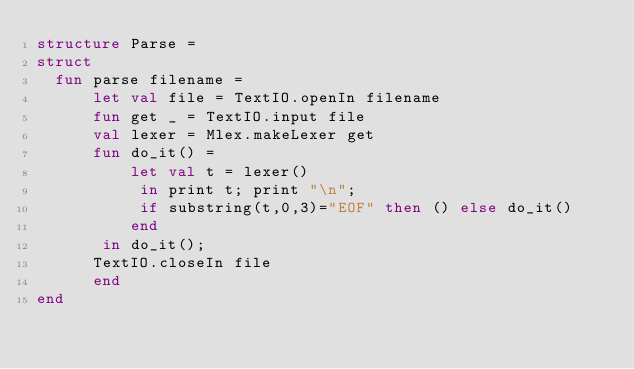<code> <loc_0><loc_0><loc_500><loc_500><_SML_>structure Parse =
struct 
  fun parse filename =
      let val file = TextIO.openIn filename
	  fun get _ = TextIO.input file
	  val lexer = Mlex.makeLexer get
	  fun do_it() =
	      let val t = lexer()
	       in print t; print "\n";
		   if substring(t,0,3)="EOF" then () else do_it()
	      end
       in do_it();
	  TextIO.closeIn file
      end
end

</code> 